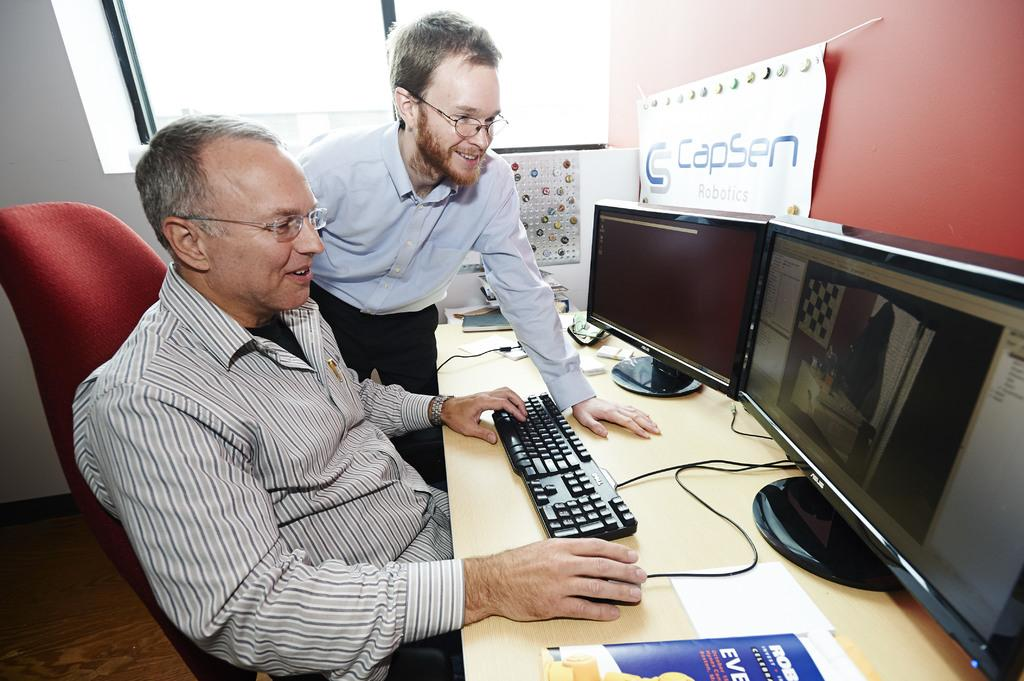<image>
Provide a brief description of the given image. Two men who work at Capsen Robotics looking at a black duel screen monitor. 